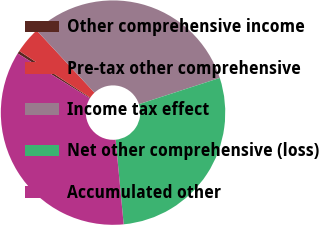Convert chart. <chart><loc_0><loc_0><loc_500><loc_500><pie_chart><fcel>Other comprehensive income<fcel>Pre-tax other comprehensive<fcel>Income tax effect<fcel>Net other comprehensive (loss)<fcel>Accumulated other<nl><fcel>0.41%<fcel>3.83%<fcel>31.92%<fcel>28.49%<fcel>35.35%<nl></chart> 